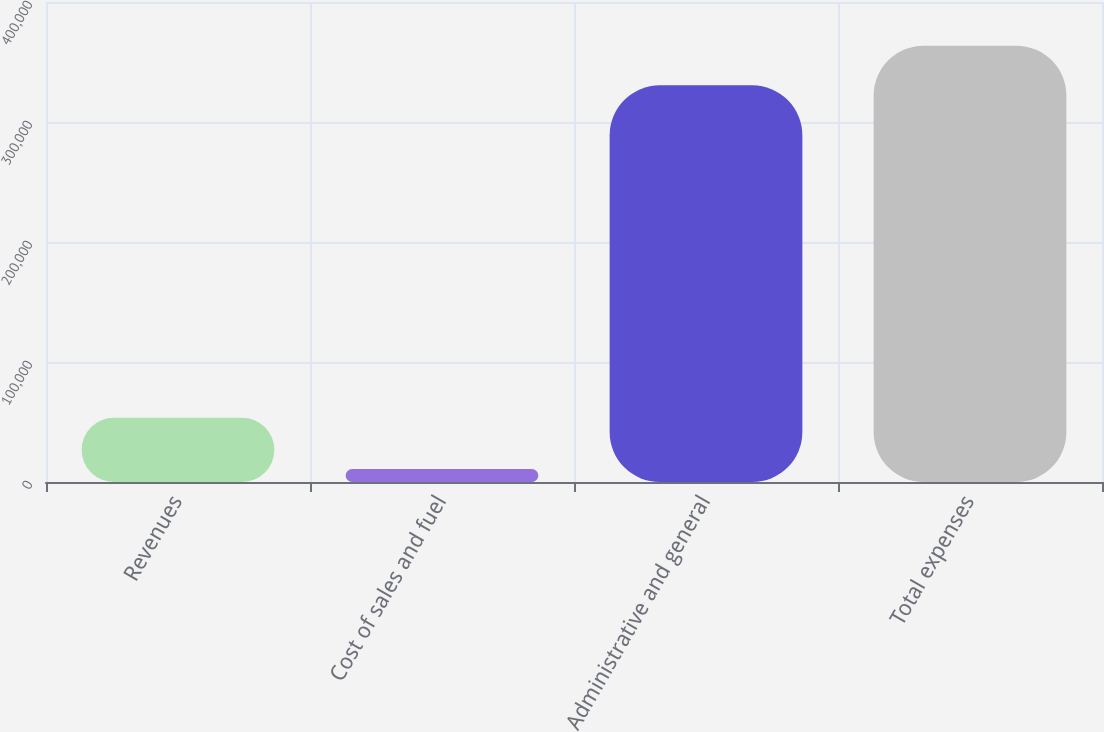Convert chart. <chart><loc_0><loc_0><loc_500><loc_500><bar_chart><fcel>Revenues<fcel>Cost of sales and fuel<fcel>Administrative and general<fcel>Total expenses<nl><fcel>53526<fcel>10835<fcel>330541<fcel>363595<nl></chart> 